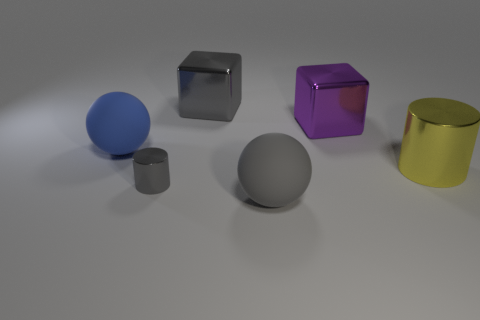Add 1 blue shiny cubes. How many objects exist? 7 Subtract all cylinders. How many objects are left? 4 Subtract 0 brown balls. How many objects are left? 6 Subtract all cyan things. Subtract all gray shiny blocks. How many objects are left? 5 Add 4 large yellow metal cylinders. How many large yellow metal cylinders are left? 5 Add 5 large blue spheres. How many large blue spheres exist? 6 